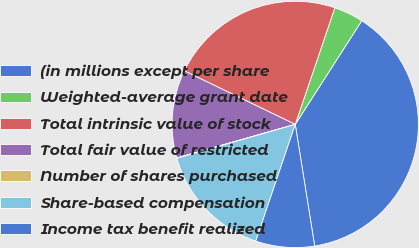Convert chart to OTSL. <chart><loc_0><loc_0><loc_500><loc_500><pie_chart><fcel>(in millions except per share<fcel>Weighted-average grant date<fcel>Total intrinsic value of stock<fcel>Total fair value of restricted<fcel>Number of shares purchased<fcel>Share-based compensation<fcel>Income tax benefit realized<nl><fcel>38.4%<fcel>3.87%<fcel>23.05%<fcel>11.55%<fcel>0.04%<fcel>15.38%<fcel>7.71%<nl></chart> 